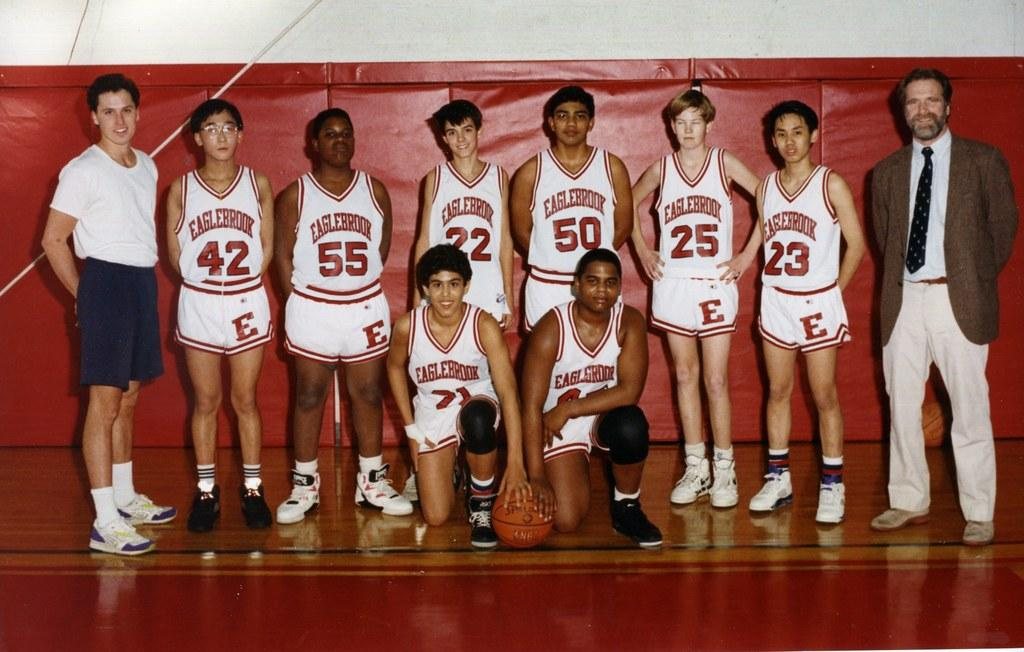<image>
Create a compact narrative representing the image presented. A group of male basketball players are wearing jerseys that say Eaglebrook. 